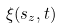<formula> <loc_0><loc_0><loc_500><loc_500>\xi ( s _ { z } , t )</formula> 